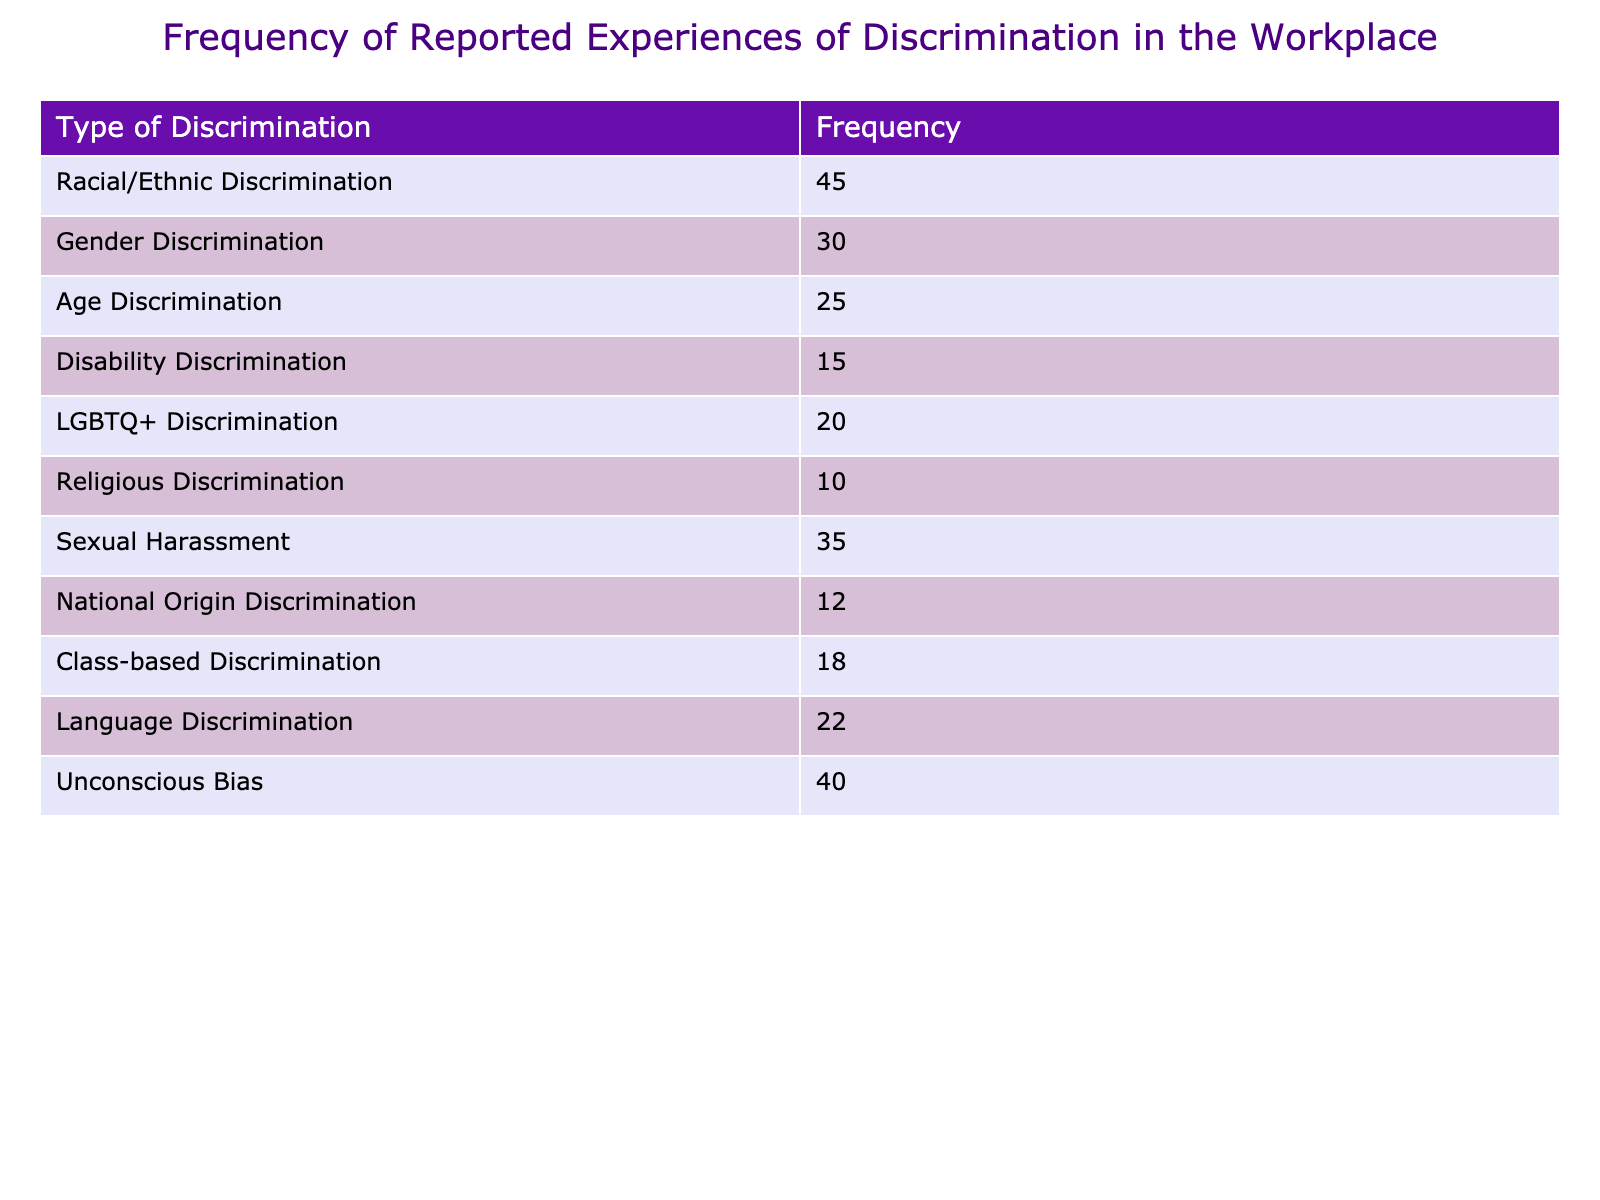What is the frequency of racial/ethnic discrimination in the workplace? The table shows that racial/ethnic discrimination has a frequency of 45.
Answer: 45 What type of discrimination has the highest reported frequency? By observing the table, racial/ethnic discrimination has the highest frequency at 45.
Answer: Racial/Ethnic Discrimination What is the total frequency of discrimination experiences reported in the table? Adding all the frequencies: 45 + 30 + 25 + 15 + 20 + 10 + 35 + 12 + 18 + 22 + 40 =  307.
Answer: 307 Is the frequency of disability discrimination higher than that of LGBTQ+ discrimination? The table shows disability discrimination has a frequency of 15, while LGBTQ+ discrimination has a frequency of 20. Thus, the statement is false.
Answer: No What is the difference in frequency between sexual harassment and gender discrimination? Sexual harassment has a frequency of 35 and gender discrimination has a frequency of 30. The difference is 35 - 30 = 5.
Answer: 5 Is the number of reported experiences of unconscious bias greater than that of national origin discrimination? Unconscious bias has a frequency of 40, and national origin discrimination has 12. Therefore, this statement is true.
Answer: Yes What percentage of the total reported experiences does language discrimination represent? The frequency of language discrimination is 22. The total frequency is 307. Thus, the percentage is (22 / 307) * 100 = 7.16%.
Answer: 7.16% If we combine the frequencies of gender discrimination, sexual harassment, and age discrimination, what is the total? The frequencies are gender discrimination (30), sexual harassment (35), and age discrimination (25). So, 30 + 35 + 25 = 90.
Answer: 90 Which type of discrimination has the lowest reported frequency? By examining the table, religious discrimination has the lowest frequency at 10.
Answer: Religious Discrimination 